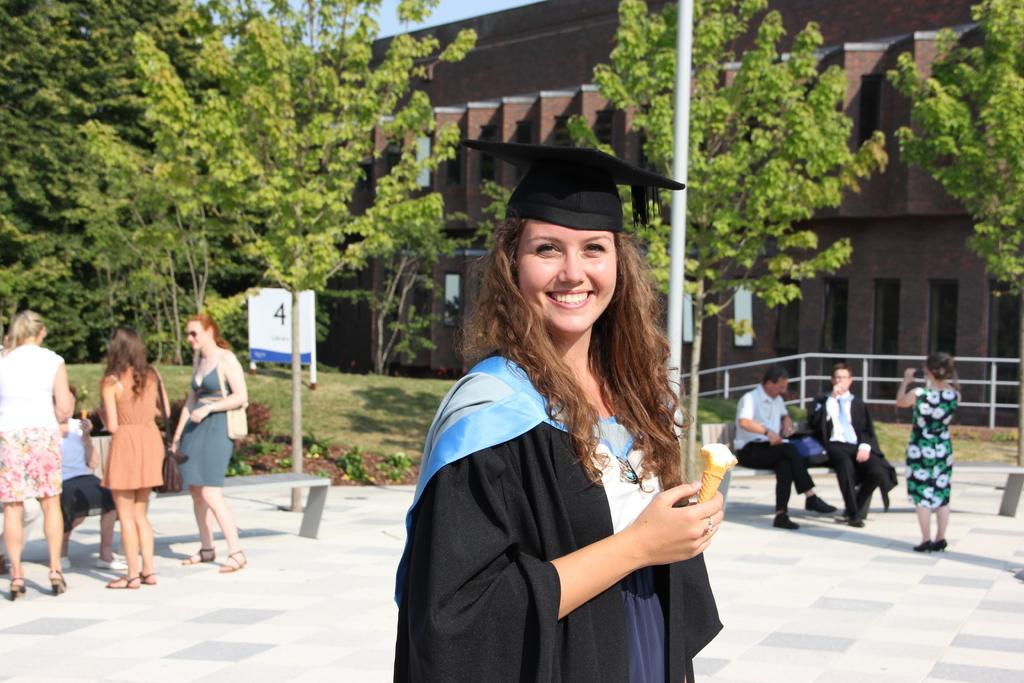Could you give a brief overview of what you see in this image? In the center of the image, we can see a lady standing and wearing coat and a hat and holding an ice cream. In the background, there are trees, poles, buildings and we can see some people and there are benches and there is a railing and there are boards. At the bottom, there is a road. 